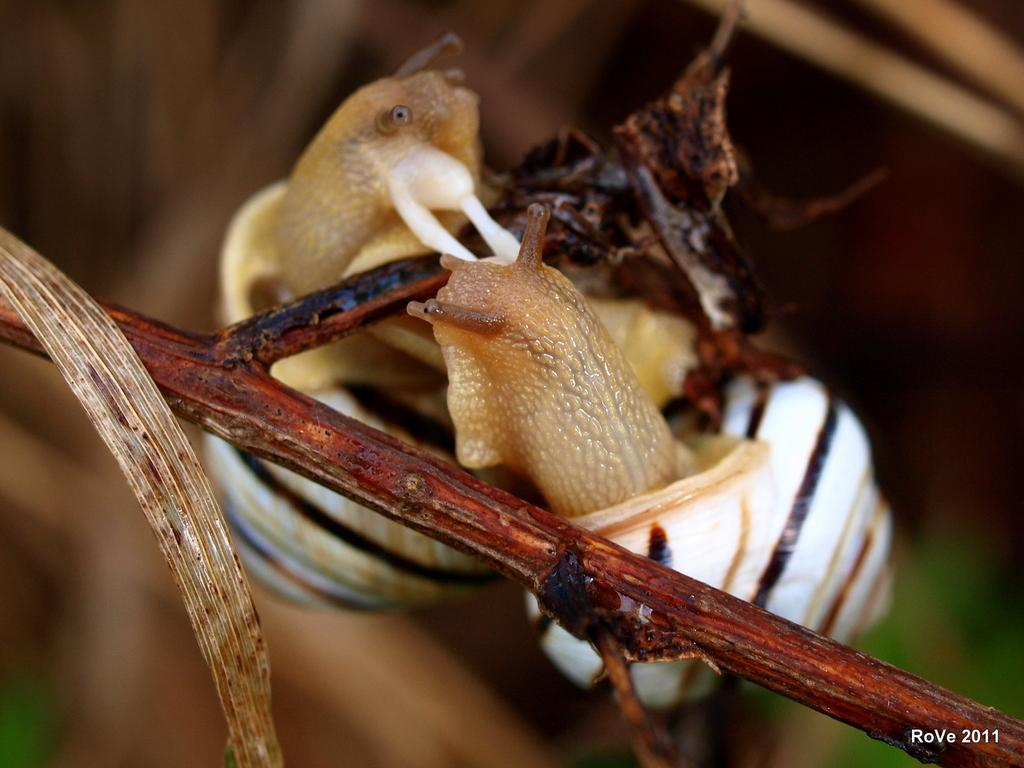What type of animal is in the image? There is a snail in the image. What is the snail resting on or near in the image? There is a tree stem in the image. What color is the background of the image? The background of the image appears to be black. What language is the snail speaking in the image? Snails do not have the ability to speak any language, so this question cannot be answered. 